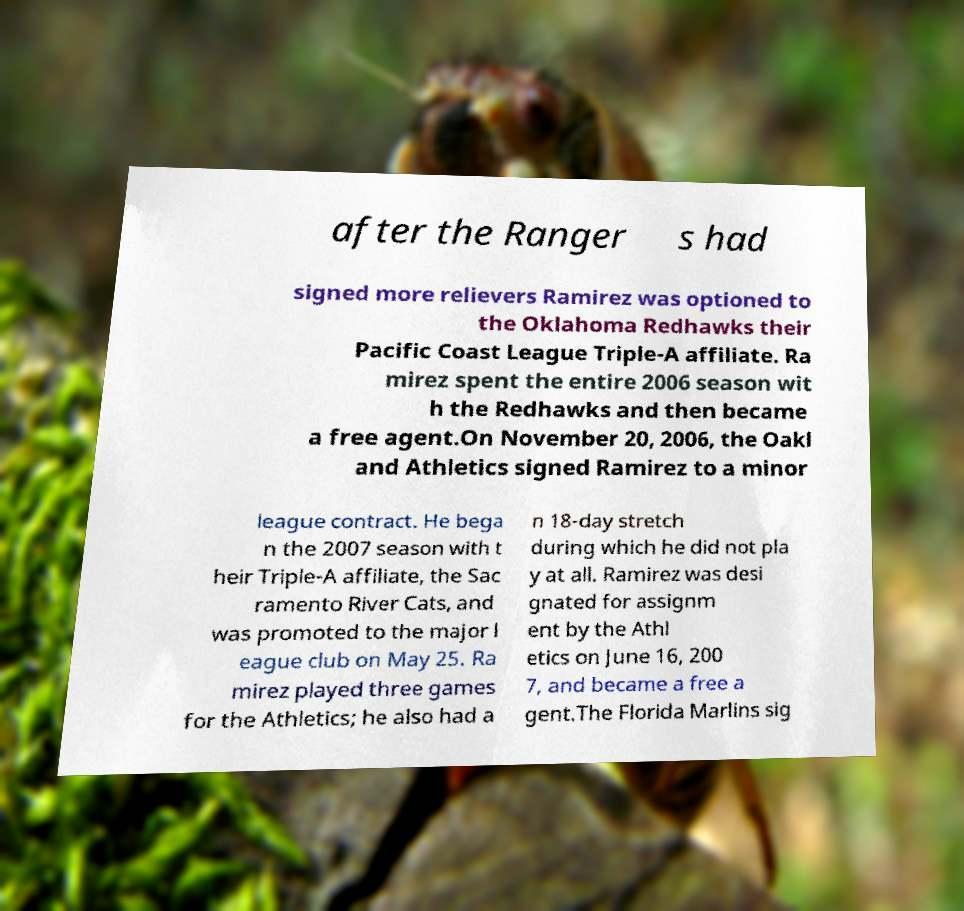Please identify and transcribe the text found in this image. after the Ranger s had signed more relievers Ramirez was optioned to the Oklahoma Redhawks their Pacific Coast League Triple-A affiliate. Ra mirez spent the entire 2006 season wit h the Redhawks and then became a free agent.On November 20, 2006, the Oakl and Athletics signed Ramirez to a minor league contract. He bega n the 2007 season with t heir Triple-A affiliate, the Sac ramento River Cats, and was promoted to the major l eague club on May 25. Ra mirez played three games for the Athletics; he also had a n 18-day stretch during which he did not pla y at all. Ramirez was desi gnated for assignm ent by the Athl etics on June 16, 200 7, and became a free a gent.The Florida Marlins sig 